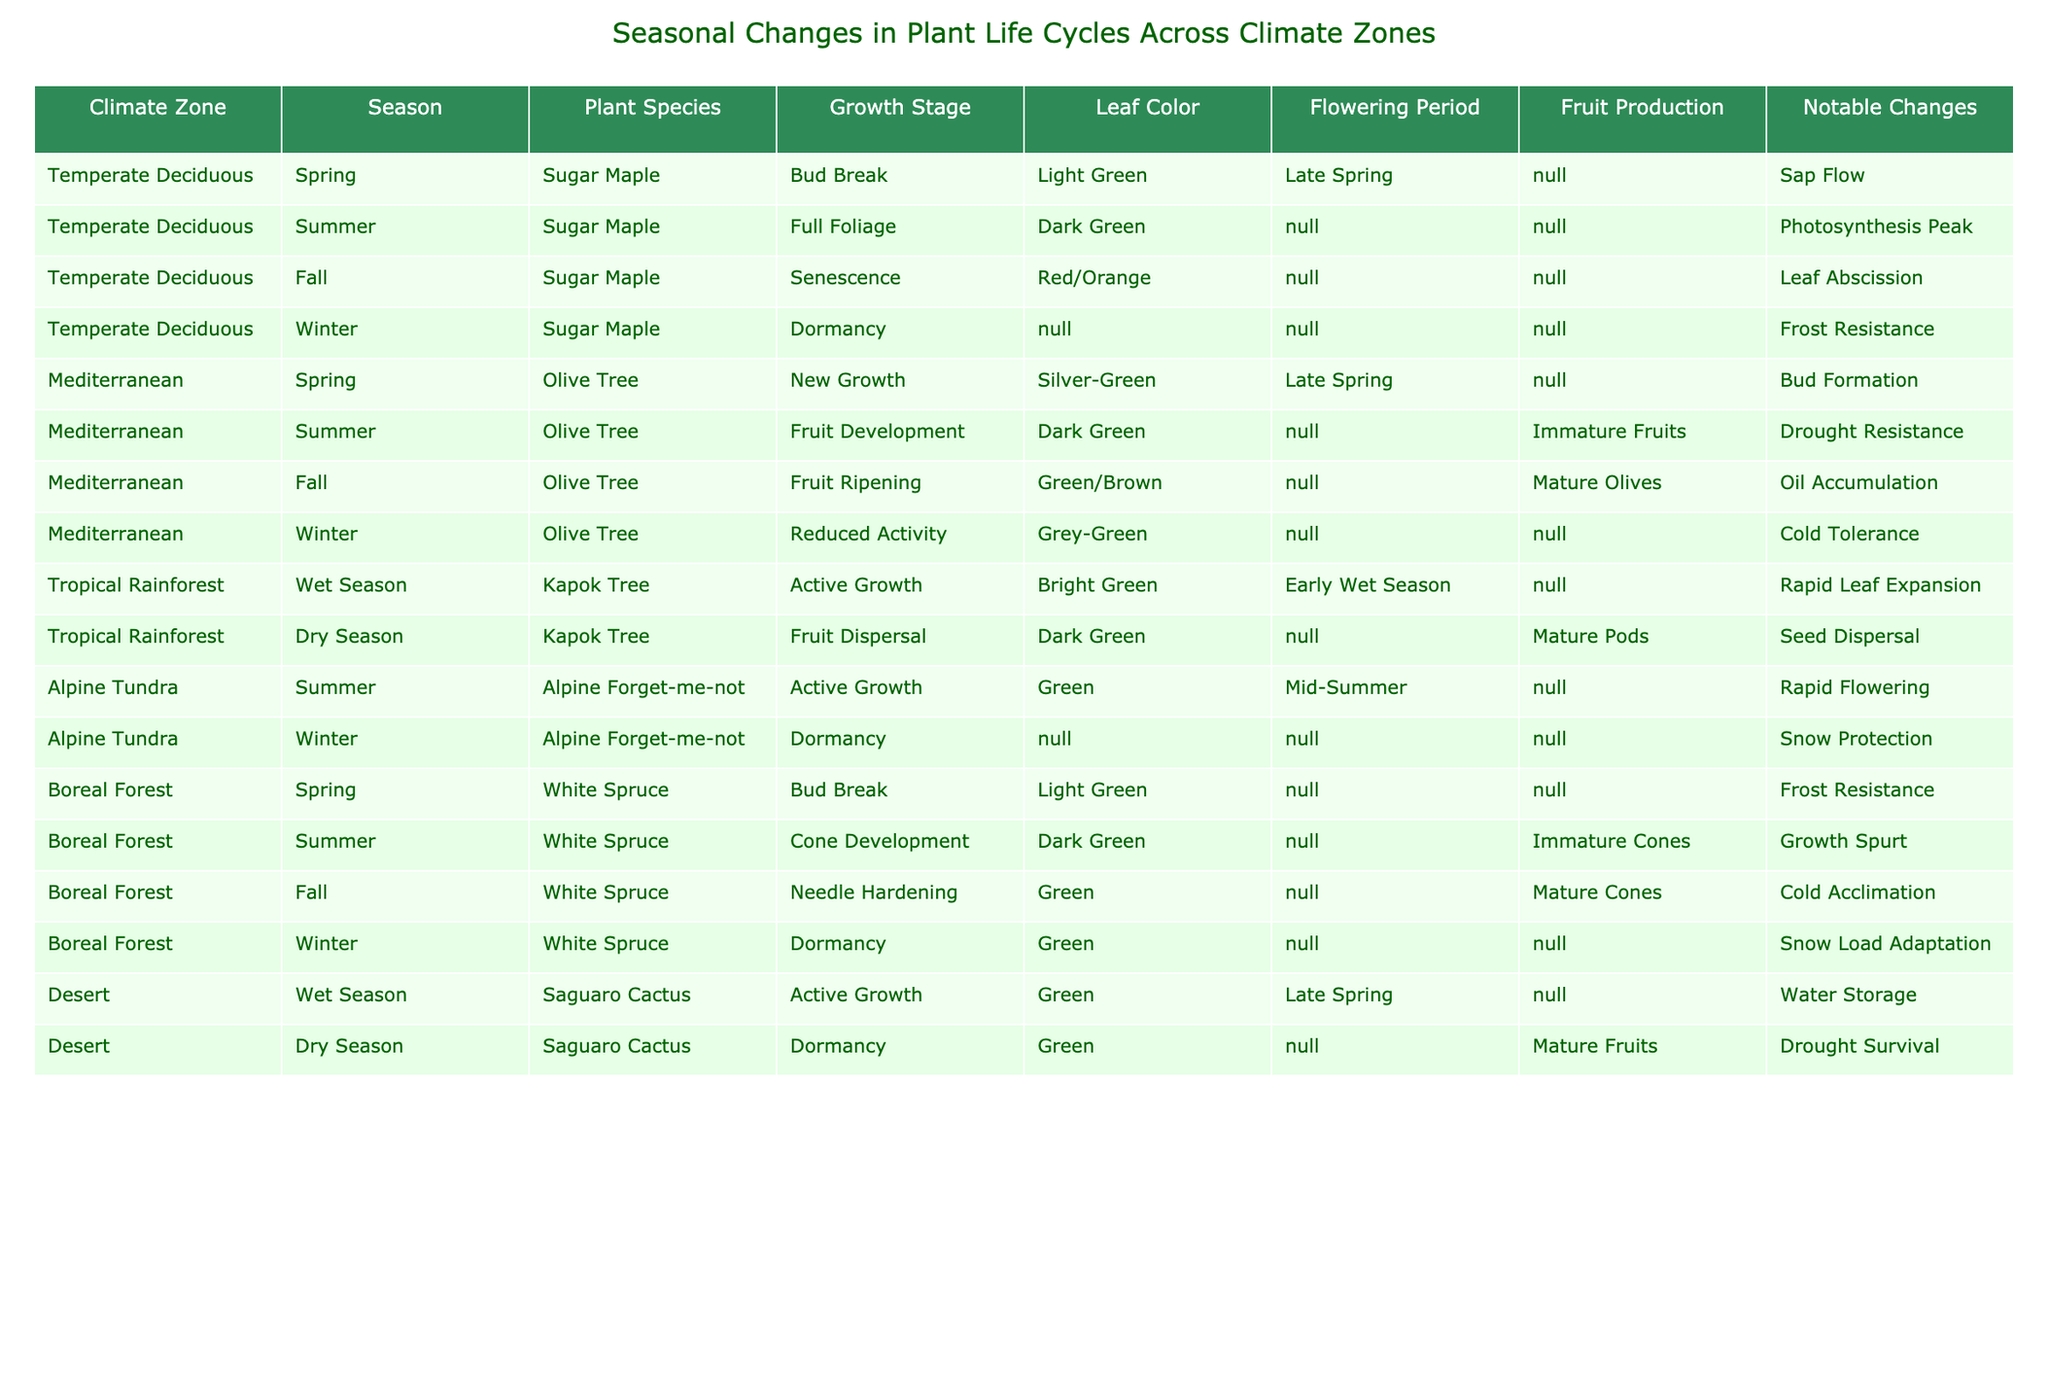What is the leaf color of the Sugar Maple in fall? According to the table, during the fall season, the Sugar Maple has a leaf color of Red/Orange. This is directly referenced in the row corresponding to the Temperate Deciduous climate zone, Fall season.
Answer: Red/Orange Which plant species undergoes dormancy during winter in the Boreal Forest? The table indicates that the White Spruce is the plant species that goes into dormancy during the winter season in the Boreal Forest climate zone. This is identifiable from the relevant row in the table.
Answer: White Spruce In which season does the Olive Tree exhibit fruit ripening? The Olive Tree shows fruit ripening during the fall season. This can be found in the Mediterranean climate zone section of the table that specifies the fall season details.
Answer: Fall Is there any plant species that has a flowering period in the winter? Reviewing the provided data shows that none of the listed plant species have a flowering period in winter, as all referenced flowering periods either occur in spring or summer. Thus, the answer to this question is no.
Answer: No During which season does the Saguaro Cactus actively grow? The Saguaro Cactus actively grows during the wet season, as indicated in the relevant row for the Desert climate zone of the table.
Answer: Wet Season What notable change occurs for the Olive Tree in spring? The notable change for the Olive Tree in spring is Bud Formation, as per the row detailing its attributes in that season within the Mediterranean climate zone.
Answer: Bud Formation How many different growth stages are listed for the Sugar Maple across all seasons in the Temperate Deciduous zone? By examining the table entries for the Sugar Maple within the Temperate Deciduous zone, there are four growth stages specified: Bud Break, Full Foliage, Senescence, and Dormancy. Therefore, the total number of different growth stages is four.
Answer: 4 Which climate zone has a plant that experiences rapid flowering in summer? The Alpine Tundra climate zone features the Alpine Forget-me-not, which is noted as experiencing active growth and rapid flowering in summer according to its data in the table.
Answer: Alpine Tundra 